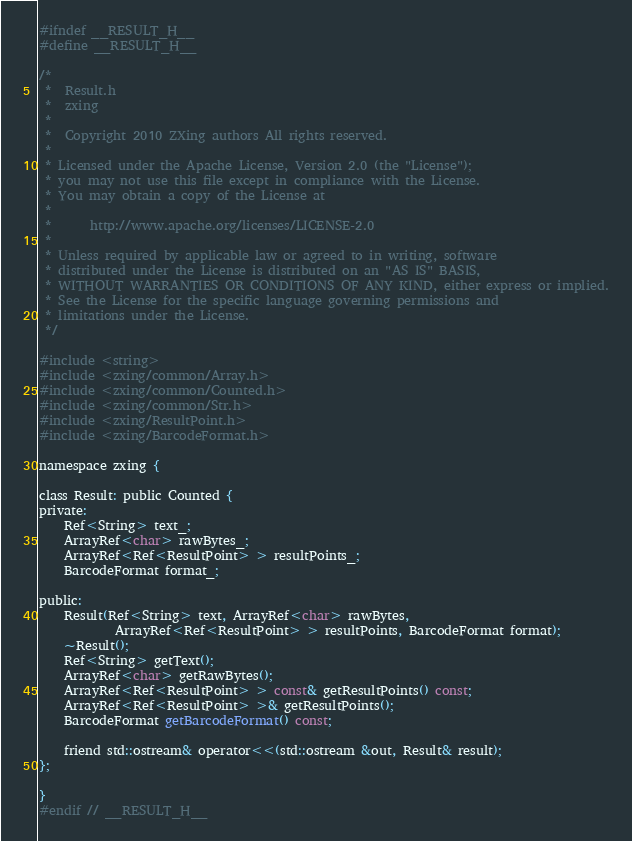Convert code to text. <code><loc_0><loc_0><loc_500><loc_500><_C_>#ifndef __RESULT_H__
#define __RESULT_H__

/*
 *  Result.h
 *  zxing
 *
 *  Copyright 2010 ZXing authors All rights reserved.
 *
 * Licensed under the Apache License, Version 2.0 (the "License");
 * you may not use this file except in compliance with the License.
 * You may obtain a copy of the License at
 *
 *      http://www.apache.org/licenses/LICENSE-2.0
 *
 * Unless required by applicable law or agreed to in writing, software
 * distributed under the License is distributed on an "AS IS" BASIS,
 * WITHOUT WARRANTIES OR CONDITIONS OF ANY KIND, either express or implied.
 * See the License for the specific language governing permissions and
 * limitations under the License.
 */

#include <string>
#include <zxing/common/Array.h>
#include <zxing/common/Counted.h>
#include <zxing/common/Str.h>
#include <zxing/ResultPoint.h>
#include <zxing/BarcodeFormat.h>

namespace zxing {

class Result: public Counted {
private:
    Ref<String> text_;
    ArrayRef<char> rawBytes_;
    ArrayRef<Ref<ResultPoint> > resultPoints_;
    BarcodeFormat format_;

public:
    Result(Ref<String> text, ArrayRef<char> rawBytes,
            ArrayRef<Ref<ResultPoint> > resultPoints, BarcodeFormat format);
    ~Result();
    Ref<String> getText();
    ArrayRef<char> getRawBytes();
    ArrayRef<Ref<ResultPoint> > const& getResultPoints() const;
    ArrayRef<Ref<ResultPoint> >& getResultPoints();
    BarcodeFormat getBarcodeFormat() const;

    friend std::ostream& operator<<(std::ostream &out, Result& result);
};

}
#endif // __RESULT_H__
</code> 